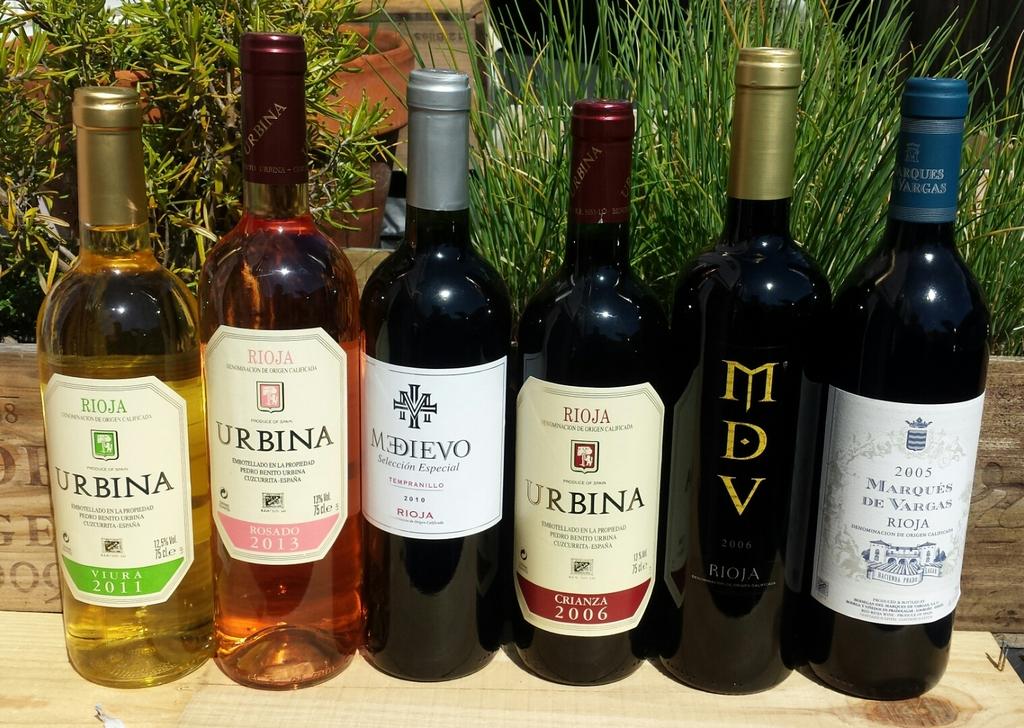What year is the first bottle on the left?
Offer a terse response. 2011. What brand is in gold letters?
Your answer should be compact. Mdv. 